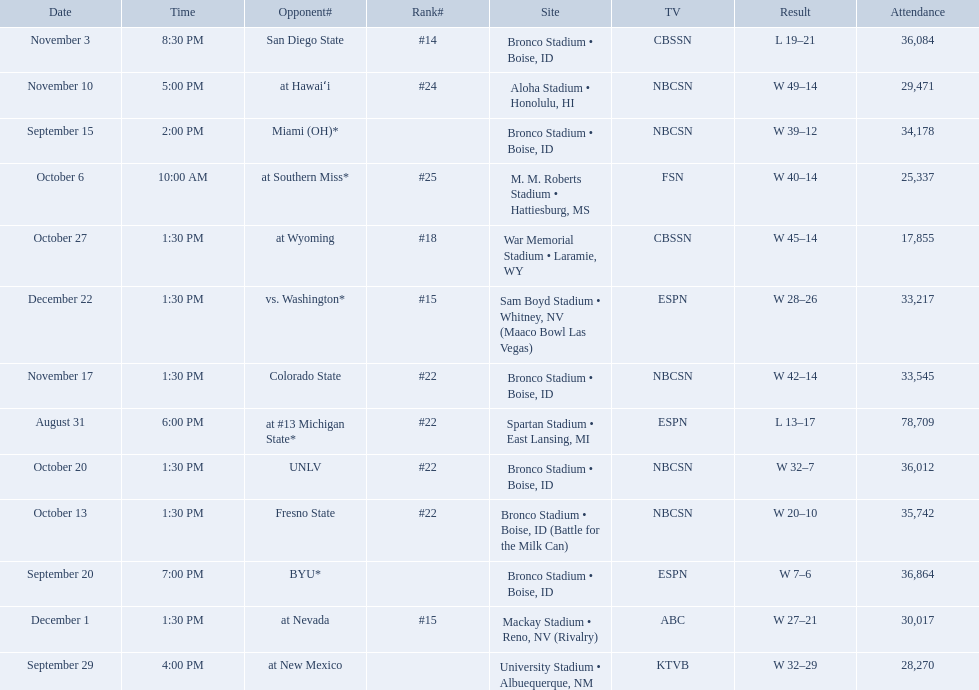What are the opponent teams of the 2012 boise state broncos football team? At #13 michigan state*, miami (oh)*, byu*, at new mexico, at southern miss*, fresno state, unlv, at wyoming, san diego state, at hawaiʻi, colorado state, at nevada, vs. washington*. Would you mind parsing the complete table? {'header': ['Date', 'Time', 'Opponent#', 'Rank#', 'Site', 'TV', 'Result', 'Attendance'], 'rows': [['November 3', '8:30 PM', 'San Diego State', '#14', 'Bronco Stadium • Boise, ID', 'CBSSN', 'L\xa019–21', '36,084'], ['November 10', '5:00 PM', 'at\xa0Hawaiʻi', '#24', 'Aloha Stadium • Honolulu, HI', 'NBCSN', 'W\xa049–14', '29,471'], ['September 15', '2:00 PM', 'Miami (OH)*', '', 'Bronco Stadium • Boise, ID', 'NBCSN', 'W\xa039–12', '34,178'], ['October 6', '10:00 AM', 'at\xa0Southern Miss*', '#25', 'M. M. Roberts Stadium • Hattiesburg, MS', 'FSN', 'W\xa040–14', '25,337'], ['October 27', '1:30 PM', 'at\xa0Wyoming', '#18', 'War Memorial Stadium • Laramie, WY', 'CBSSN', 'W\xa045–14', '17,855'], ['December 22', '1:30 PM', 'vs.\xa0Washington*', '#15', 'Sam Boyd Stadium • Whitney, NV (Maaco Bowl Las Vegas)', 'ESPN', 'W\xa028–26', '33,217'], ['November 17', '1:30 PM', 'Colorado State', '#22', 'Bronco Stadium • Boise, ID', 'NBCSN', 'W\xa042–14', '33,545'], ['August 31', '6:00 PM', 'at\xa0#13\xa0Michigan State*', '#22', 'Spartan Stadium • East Lansing, MI', 'ESPN', 'L\xa013–17', '78,709'], ['October 20', '1:30 PM', 'UNLV', '#22', 'Bronco Stadium • Boise, ID', 'NBCSN', 'W\xa032–7', '36,012'], ['October 13', '1:30 PM', 'Fresno State', '#22', 'Bronco Stadium • Boise, ID (Battle for the Milk Can)', 'NBCSN', 'W\xa020–10', '35,742'], ['September 20', '7:00 PM', 'BYU*', '', 'Bronco Stadium • Boise, ID', 'ESPN', 'W\xa07–6', '36,864'], ['December 1', '1:30 PM', 'at\xa0Nevada', '#15', 'Mackay Stadium • Reno, NV (Rivalry)', 'ABC', 'W\xa027–21', '30,017'], ['September 29', '4:00 PM', 'at\xa0New Mexico', '', 'University Stadium • Albuequerque, NM', 'KTVB', 'W\xa032–29', '28,270']]} How has the highest rank of these opponents? San Diego State. 